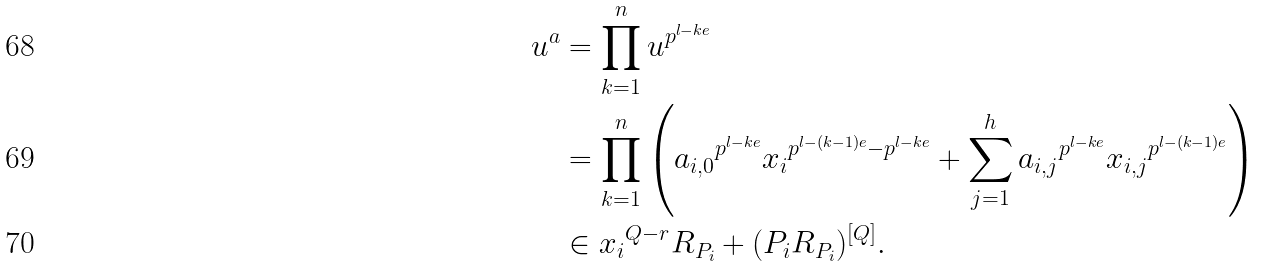<formula> <loc_0><loc_0><loc_500><loc_500>u ^ { a } & = \prod _ { k = 1 } ^ { n } u ^ { p ^ { l - k e } } \\ & = \prod _ { k = 1 } ^ { n } \left ( { a _ { i , 0 } } ^ { p ^ { l - k e } } { x _ { i } } ^ { p ^ { l - ( k - 1 ) e } - p ^ { l - k e } } + \sum _ { j = 1 } ^ { h } { a _ { i , j } } ^ { p ^ { l - k e } } { x _ { i , j } } ^ { p ^ { l - ( k - 1 ) e } } \right ) \\ & \in { x _ { i } } ^ { Q - r } R _ { P _ { i } } + ( P _ { i } R _ { P _ { i } } ) ^ { [ Q ] } .</formula> 